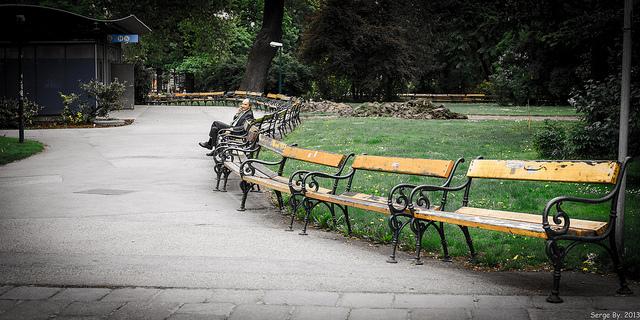What color is the shingle sign?
Quick response, please. Blue. Approximately how old are the benches pictured?
Concise answer only. 30 years. Is there a person sitting on the bench?
Be succinct. Yes. 